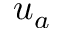<formula> <loc_0><loc_0><loc_500><loc_500>u _ { a }</formula> 